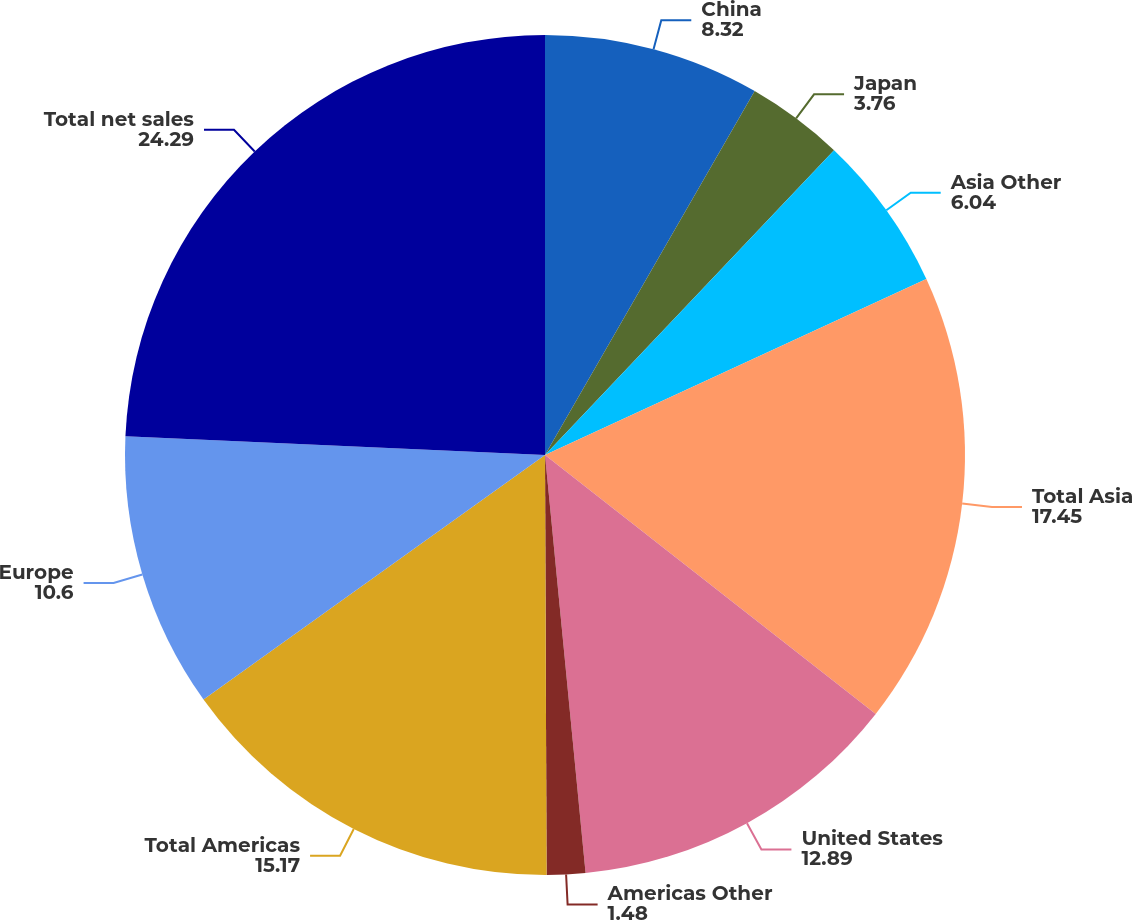<chart> <loc_0><loc_0><loc_500><loc_500><pie_chart><fcel>China<fcel>Japan<fcel>Asia Other<fcel>Total Asia<fcel>United States<fcel>Americas Other<fcel>Total Americas<fcel>Europe<fcel>Total net sales<nl><fcel>8.32%<fcel>3.76%<fcel>6.04%<fcel>17.45%<fcel>12.89%<fcel>1.48%<fcel>15.17%<fcel>10.6%<fcel>24.29%<nl></chart> 